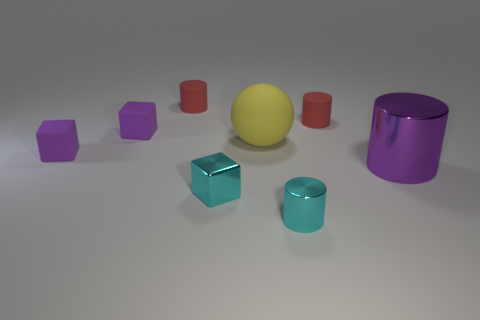There is a cylinder that is in front of the purple metal object; does it have the same color as the metal cube?
Make the answer very short. Yes. What is the size of the purple cylinder that is on the right side of the big yellow thing?
Your answer should be very brief. Large. There is a cyan object on the left side of the cyan thing on the right side of the small cyan block; what is its shape?
Make the answer very short. Cube. There is another metal thing that is the same shape as the big purple metal thing; what is its color?
Your answer should be compact. Cyan. There is a cyan shiny cylinder that is in front of the purple metallic thing; is its size the same as the small metal cube?
Provide a short and direct response. Yes. There is a tiny object that is the same color as the tiny metal cylinder; what is its shape?
Give a very brief answer. Cube. How many small cyan objects have the same material as the large purple thing?
Offer a very short reply. 2. The small purple object behind the purple block that is in front of the tiny matte block that is behind the large yellow sphere is made of what material?
Keep it short and to the point. Rubber. There is a large thing that is in front of the large rubber sphere to the left of the large purple cylinder; what is its color?
Your answer should be very brief. Purple. What color is the metallic cylinder that is the same size as the cyan cube?
Give a very brief answer. Cyan. 